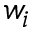<formula> <loc_0><loc_0><loc_500><loc_500>w _ { i }</formula> 